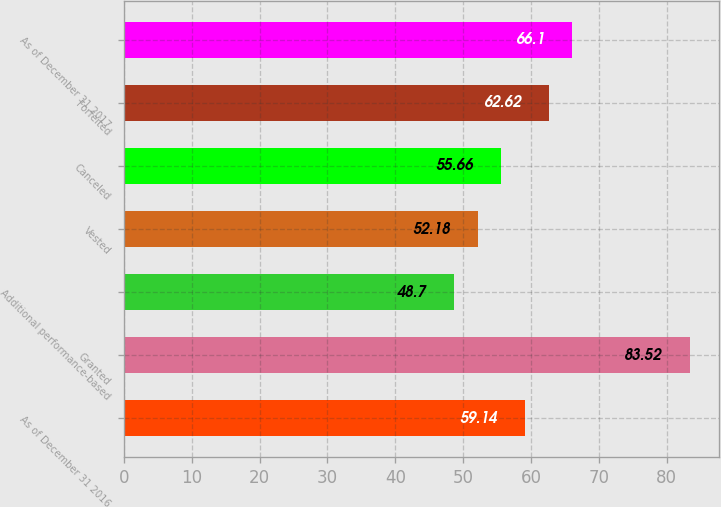Convert chart to OTSL. <chart><loc_0><loc_0><loc_500><loc_500><bar_chart><fcel>As of December 31 2016<fcel>Granted<fcel>Additional performance-based<fcel>Vested<fcel>Canceled<fcel>Forfeited<fcel>As of December 31 2017<nl><fcel>59.14<fcel>83.52<fcel>48.7<fcel>52.18<fcel>55.66<fcel>62.62<fcel>66.1<nl></chart> 